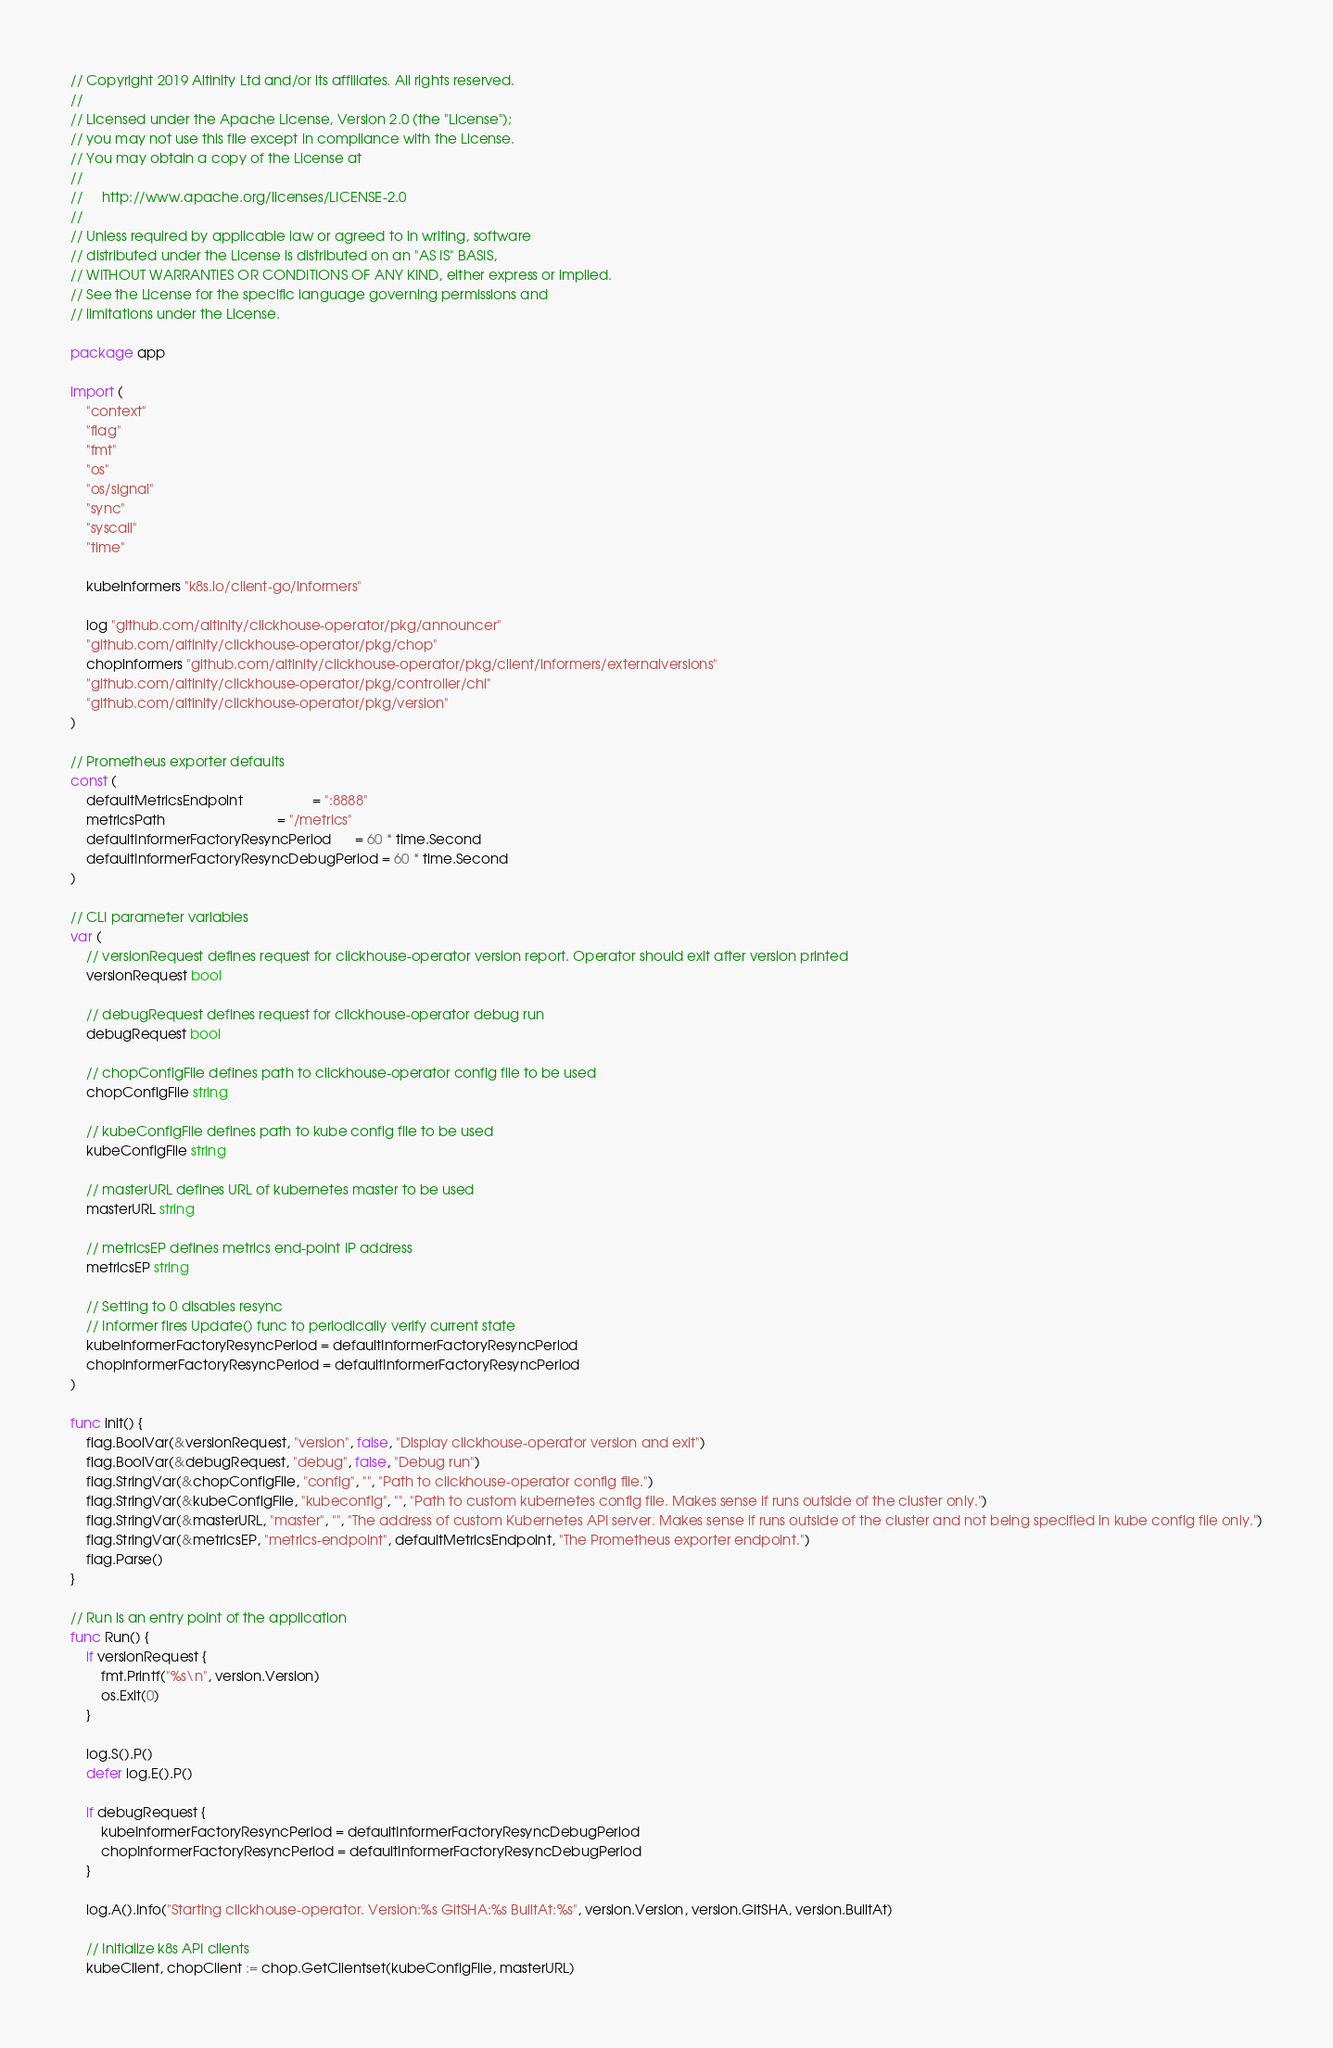Convert code to text. <code><loc_0><loc_0><loc_500><loc_500><_Go_>// Copyright 2019 Altinity Ltd and/or its affiliates. All rights reserved.
//
// Licensed under the Apache License, Version 2.0 (the "License");
// you may not use this file except in compliance with the License.
// You may obtain a copy of the License at
//
//     http://www.apache.org/licenses/LICENSE-2.0
//
// Unless required by applicable law or agreed to in writing, software
// distributed under the License is distributed on an "AS IS" BASIS,
// WITHOUT WARRANTIES OR CONDITIONS OF ANY KIND, either express or implied.
// See the License for the specific language governing permissions and
// limitations under the License.

package app

import (
	"context"
	"flag"
	"fmt"
	"os"
	"os/signal"
	"sync"
	"syscall"
	"time"

	kubeinformers "k8s.io/client-go/informers"

	log "github.com/altinity/clickhouse-operator/pkg/announcer"
	"github.com/altinity/clickhouse-operator/pkg/chop"
	chopinformers "github.com/altinity/clickhouse-operator/pkg/client/informers/externalversions"
	"github.com/altinity/clickhouse-operator/pkg/controller/chi"
	"github.com/altinity/clickhouse-operator/pkg/version"
)

// Prometheus exporter defaults
const (
	defaultMetricsEndpoint                  = ":8888"
	metricsPath                             = "/metrics"
	defaultInformerFactoryResyncPeriod      = 60 * time.Second
	defaultInformerFactoryResyncDebugPeriod = 60 * time.Second
)

// CLI parameter variables
var (
	// versionRequest defines request for clickhouse-operator version report. Operator should exit after version printed
	versionRequest bool

	// debugRequest defines request for clickhouse-operator debug run
	debugRequest bool

	// chopConfigFile defines path to clickhouse-operator config file to be used
	chopConfigFile string

	// kubeConfigFile defines path to kube config file to be used
	kubeConfigFile string

	// masterURL defines URL of kubernetes master to be used
	masterURL string

	// metricsEP defines metrics end-point IP address
	metricsEP string

	// Setting to 0 disables resync
	// Informer fires Update() func to periodically verify current state
	kubeInformerFactoryResyncPeriod = defaultInformerFactoryResyncPeriod
	chopInformerFactoryResyncPeriod = defaultInformerFactoryResyncPeriod
)

func init() {
	flag.BoolVar(&versionRequest, "version", false, "Display clickhouse-operator version and exit")
	flag.BoolVar(&debugRequest, "debug", false, "Debug run")
	flag.StringVar(&chopConfigFile, "config", "", "Path to clickhouse-operator config file.")
	flag.StringVar(&kubeConfigFile, "kubeconfig", "", "Path to custom kubernetes config file. Makes sense if runs outside of the cluster only.")
	flag.StringVar(&masterURL, "master", "", "The address of custom Kubernetes API server. Makes sense if runs outside of the cluster and not being specified in kube config file only.")
	flag.StringVar(&metricsEP, "metrics-endpoint", defaultMetricsEndpoint, "The Prometheus exporter endpoint.")
	flag.Parse()
}

// Run is an entry point of the application
func Run() {
	if versionRequest {
		fmt.Printf("%s\n", version.Version)
		os.Exit(0)
	}

	log.S().P()
	defer log.E().P()

	if debugRequest {
		kubeInformerFactoryResyncPeriod = defaultInformerFactoryResyncDebugPeriod
		chopInformerFactoryResyncPeriod = defaultInformerFactoryResyncDebugPeriod
	}

	log.A().Info("Starting clickhouse-operator. Version:%s GitSHA:%s BuiltAt:%s", version.Version, version.GitSHA, version.BuiltAt)

	// Initialize k8s API clients
	kubeClient, chopClient := chop.GetClientset(kubeConfigFile, masterURL)
</code> 